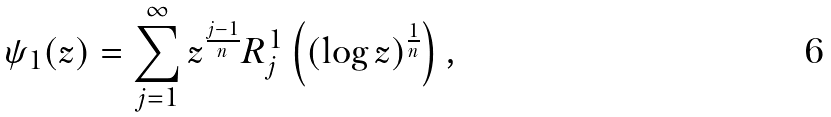Convert formula to latex. <formula><loc_0><loc_0><loc_500><loc_500>\psi _ { 1 } ( z ) = \sum _ { j = 1 } ^ { \infty } z ^ { \frac { j - 1 } { n } } R _ { j } ^ { 1 } \left ( ( \log z ) ^ { \frac { 1 } { n } } \right ) ,</formula> 